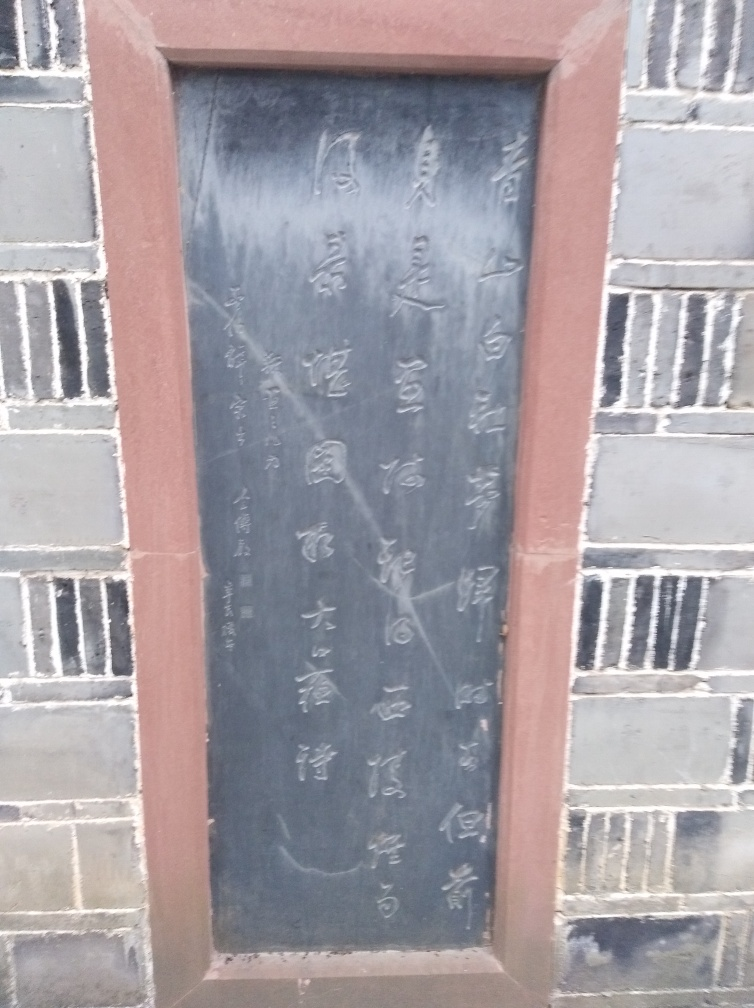In what type of location would you expect to find this tablet? Tablets such as this one are often found in culturally significant locations, like historical sites, temples, parks, or educational institutions. Given the character of the writing and the traditional style, this tablet could be situated at a historical landmark with importance to the local community or region, aimed at preserving and sharing heritage. 